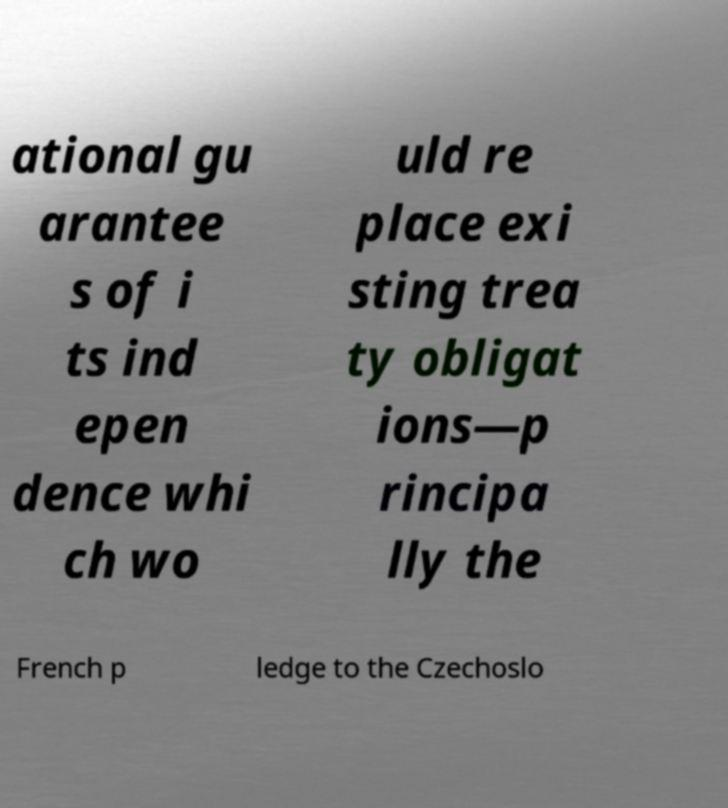What messages or text are displayed in this image? I need them in a readable, typed format. ational gu arantee s of i ts ind epen dence whi ch wo uld re place exi sting trea ty obligat ions—p rincipa lly the French p ledge to the Czechoslo 